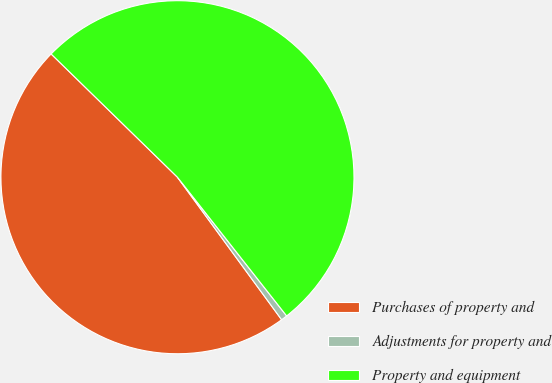Convert chart. <chart><loc_0><loc_0><loc_500><loc_500><pie_chart><fcel>Purchases of property and<fcel>Adjustments for property and<fcel>Property and equipment<nl><fcel>47.35%<fcel>0.57%<fcel>52.08%<nl></chart> 